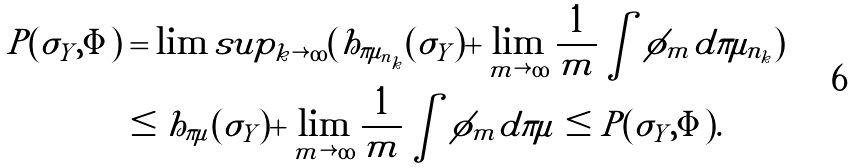Convert formula to latex. <formula><loc_0><loc_0><loc_500><loc_500>P ( \sigma _ { Y } , \Phi ) & = \lim s u p _ { k \rightarrow \infty } ( h _ { \pi \mu _ { n _ { k } } } ( \sigma _ { Y } ) + \lim _ { m \rightarrow \infty } \frac { 1 } { m } \int \phi _ { m } d \pi \mu _ { n _ { k } } ) \\ & \leq h _ { \pi \mu } ( \sigma _ { Y } ) + \lim _ { m \rightarrow \infty } \frac { 1 } { m } \int \phi _ { m } d \pi \mu \leq P ( \sigma _ { Y } , \Phi ) .</formula> 